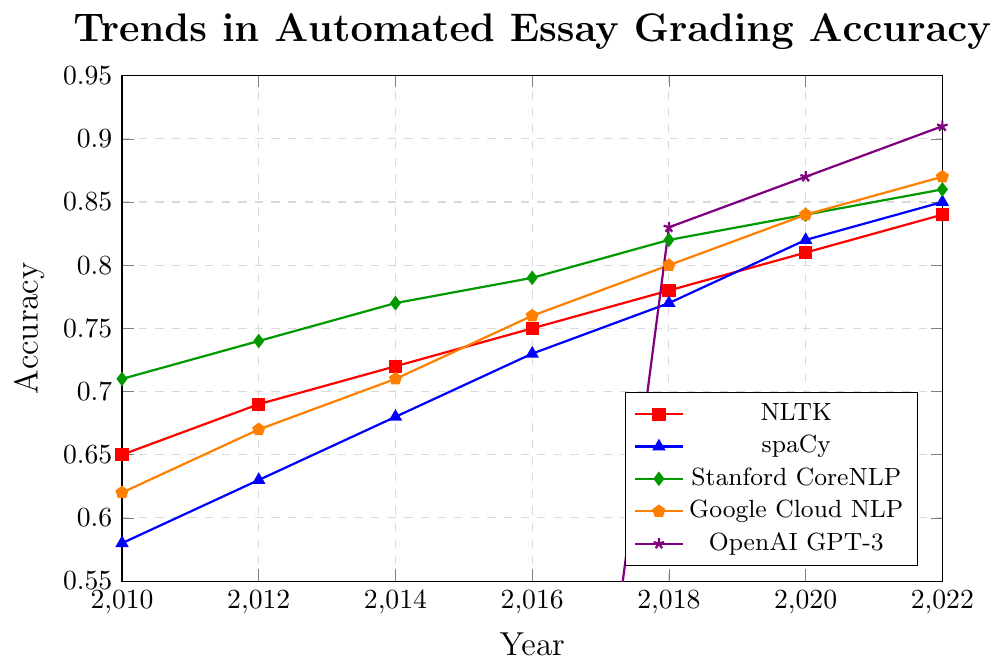What was the accuracy of Google's NLP model in 2018? To identify the accuracy of Google's NLP model in 2018, locate Google Cloud NLP in the legend and then trace the corresponding point on the line at 2018.
Answer: 0.80 How did the accuracy of NLTK compare to spaCy in 2020? To compare the accuracies in 2020, find the values for NLTK and spaCy on the graph for the year 2020 and subtract spaCy's value from NLTK's value. In 2020, NLTK's accuracy is 0.81 and spaCy's is 0.82. 0.82 - 0.81 = 0.01
Answer: 0.01 difference, spaCy is more accurate Which model had the highest accuracy in 2022? The model with the highest accuracy will be the one with the highest point on the graph for the year 2022. Locate the highest point and refer to the legend. OpenAI GPT-3 is at 0.91 in 2022.
Answer: OpenAI GPT-3 What is the average accuracy of Stanford CoreNLP from 2010 to 2022? To find the average accuracy, sum the values of Stanford CoreNLP over the given years and divide by the number of years. Adding 0.71+0.74+0.77+0.79+0.82+0.84+0.86 = 5.53. Divide this by 7 years: 5.53/7 ≈ 0.79.
Answer: 0.79 In which year did OpenAI GPT-3 first appear in the dataset and what was its accuracy? Look for the year where OpenAI GPT-3 first has a non-zero value, which can be found on the graph. The GPT-3 line begins at 2018 with an accuracy of 0.83.
Answer: 2018, 0.83 How does the accuracy trend of Google Cloud NLP from 2010 to 2022 compare to that of spaCy? To compare trends, observe the increase in accuracy for both models over the years. Google Cloud NLP starts at 0.62 and ends at 0.87. SpaCy starts at 0.58 and ends at 0.85. Both models see significant improvement, with Google Cloud NLP surpassing spaCy in each marked period.
Answer: Google Cloud NLP consistently outperformed spaCy What is the difference in accuracy between the highest and lowest model performances in 2020? Identify the highest and lowest accuracies in 2020 on the graph. OpenAI GPT-3 has the highest at 0.87; spaCy has the lowest at 0.82. The difference is 0.87 - 0.82 = 0.05.
Answer: 0.05 Which model shows a consistent increase in accuracy across all recorded years? A consistent increase can be identified by observing the graph lines that continually rise without any decrease. NLTK, spaCy, Stanford CoreNLP, and Google Cloud NLP each show consistent year-over-year increases.
Answer: NLTK, spaCy, Stanford CoreNLP, Google Cloud NLP 